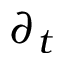Convert formula to latex. <formula><loc_0><loc_0><loc_500><loc_500>\partial _ { t }</formula> 